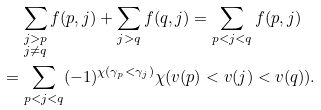Convert formula to latex. <formula><loc_0><loc_0><loc_500><loc_500>& \quad \, \sum _ { \substack { j > p \\ j \not = q } } f ( p , j ) + \sum _ { j > q } f ( q , j ) = \sum _ { p < j < q } f ( p , j ) \\ & = \sum _ { p < j < q } ( - 1 ) ^ { \chi ( \gamma _ { p } < \gamma _ { j } ) } \chi ( v ( p ) < v ( j ) < v ( q ) ) .</formula> 